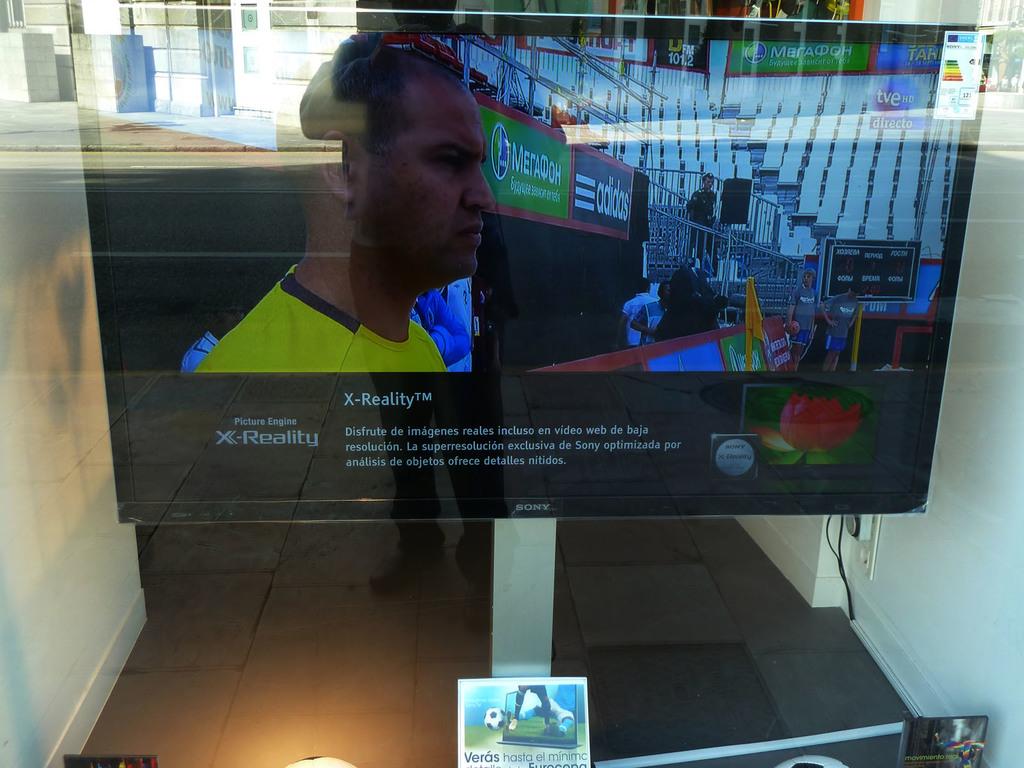Whats the name of the picture engine?
Your answer should be compact. X-reality. 